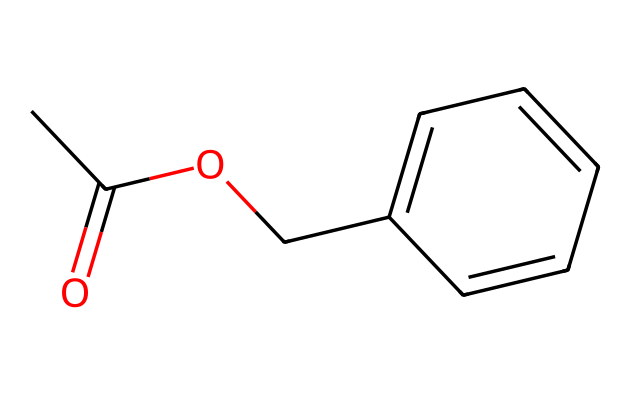What is the functional group present in this compound? This compound features a functional group characterized by a carbonyl (C=O) linked to an oxygen atom which indicates it is an ester. The SMILES representation starts with "CC(=O)OC" which confirms this presence.
Answer: ester How many carbon atoms are in this compound? By analyzing the SMILES notation, we can identify the carbon atoms: "CC" has 2, and the benzene ring "c1ccccc1" contains 6. Thus, there are a total of 2 + 6 = 8 carbon atoms.
Answer: 8 What type of aromatic system does this compound possess? The compound has a benzene ring, which is derived from its structure shown in the “c1ccccc1” part of the SMILES. A benzene ring contains six carbon atoms arranged in a cyclic structure with alternating double bonds.
Answer: benzene What is the total number of hydrogen atoms in this compound? To find the number of hydrogen atoms, we consider the valency of carbon and consider the structure. The 8 carbon atoms generally bond with 2 hydrogens each but lose some due to double bonds and functional groups. The calculations conclude that there are 8 hydrogens.
Answer: 8 What does the presence of the ester functional group suggest about the compound's properties? The ester functional group typically implies that the compound will have a characteristic fruity or floral smell and is often used in perfumery and flavoring. Observing the structure, this aligns with the jasmine essential oil's aroma.
Answer: fruity Does this compound exhibit polarity? The presence of the polar carbonyl (C=O) in the ester functional group contributes to the compound's overall polarity. Therefore, while it has a nonpolar benzene ring, the molecule overall has some polar characteristics due to the ester group.
Answer: yes 